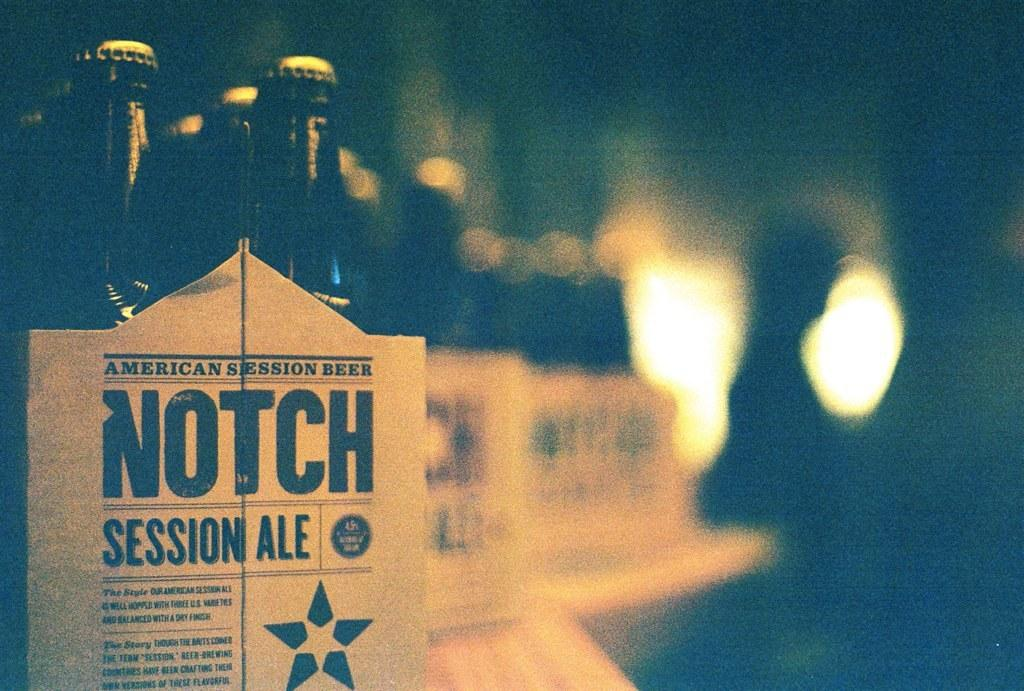<image>
Share a concise interpretation of the image provided. Packages of Notch Session Ale Beer Bottles on a line. 